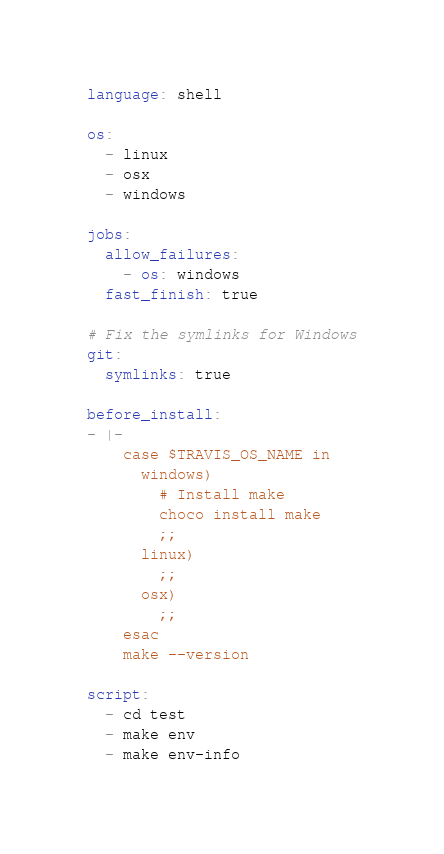Convert code to text. <code><loc_0><loc_0><loc_500><loc_500><_YAML_>language: shell

os:
  - linux
  - osx
  - windows

jobs:
  allow_failures:
    - os: windows
  fast_finish: true

# Fix the symlinks for Windows
git:
  symlinks: true

before_install:
- |-
    case $TRAVIS_OS_NAME in
      windows)
        # Install make
        choco install make
        ;;
      linux)
        ;;
      osx)
        ;;
    esac
    make --version

script:
  - cd test
  - make env
  - make env-info
</code> 